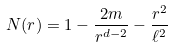<formula> <loc_0><loc_0><loc_500><loc_500>N ( r ) = 1 - \frac { 2 m } { r ^ { d - 2 } } - \frac { r ^ { 2 } } { \ell ^ { 2 } }</formula> 